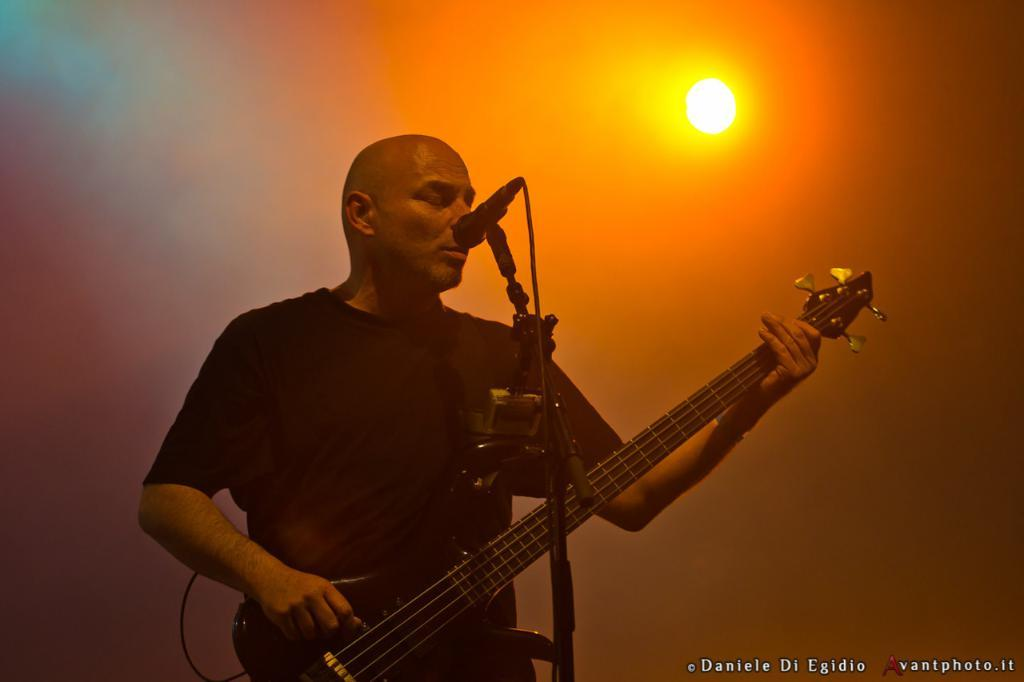What is the person in the image doing? The person is playing a guitar. What object is present in the image that is commonly used for amplifying sound? There is a microphone with a stand in the image. What type of light is visible at the top of the image? There is a focusing light visible at the top of the image. Where is the person's aunt in the image? There is no mention of an aunt in the image, so we cannot determine her location. 